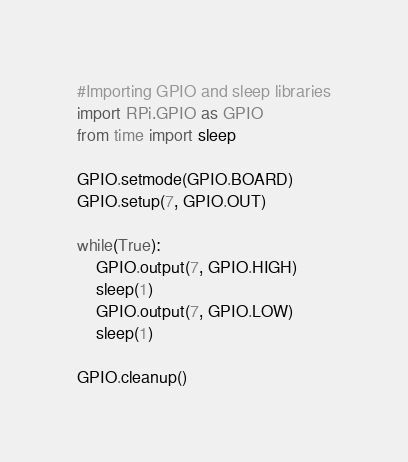<code> <loc_0><loc_0><loc_500><loc_500><_Python_>#Importing GPIO and sleep libraries
import RPi.GPIO as GPIO
from time import sleep

GPIO.setmode(GPIO.BOARD)
GPIO.setup(7, GPIO.OUT)

while(True):
    GPIO.output(7, GPIO.HIGH)
    sleep(1)
    GPIO.output(7, GPIO.LOW)
    sleep(1)

GPIO.cleanup()</code> 